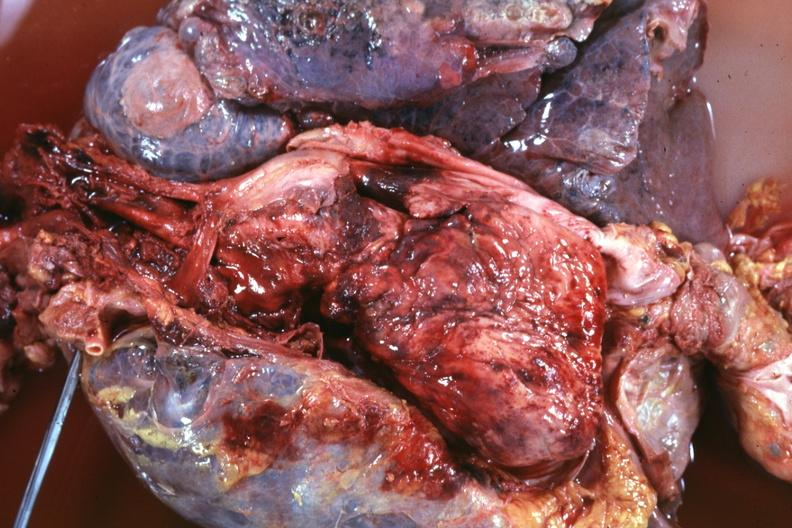how is thoracic organs dissected to show super cava and region of tumor invasion quite?
Answer the question using a single word or phrase. Good 